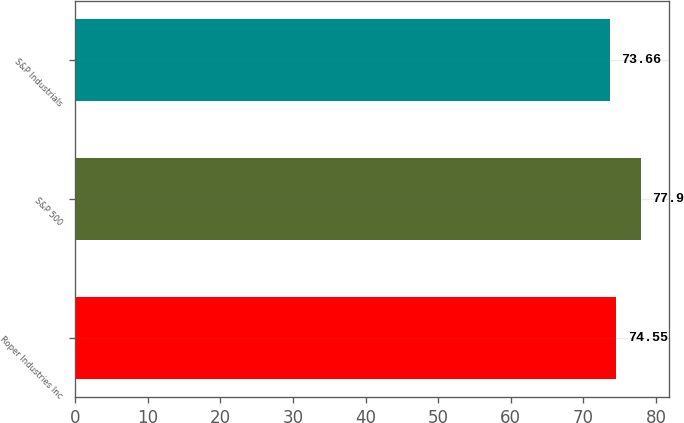Convert chart to OTSL. <chart><loc_0><loc_0><loc_500><loc_500><bar_chart><fcel>Roper Industries Inc<fcel>S&P 500<fcel>S&P Industrials<nl><fcel>74.55<fcel>77.9<fcel>73.66<nl></chart> 